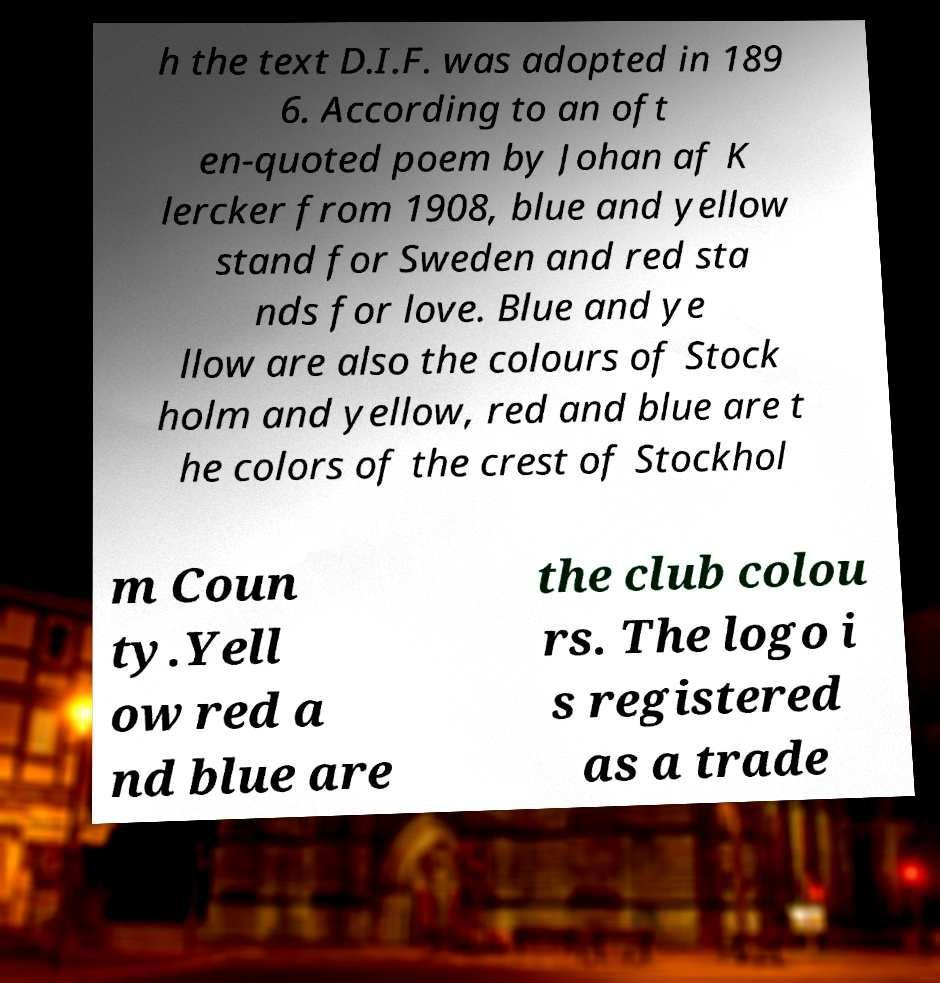Could you assist in decoding the text presented in this image and type it out clearly? h the text D.I.F. was adopted in 189 6. According to an oft en-quoted poem by Johan af K lercker from 1908, blue and yellow stand for Sweden and red sta nds for love. Blue and ye llow are also the colours of Stock holm and yellow, red and blue are t he colors of the crest of Stockhol m Coun ty.Yell ow red a nd blue are the club colou rs. The logo i s registered as a trade 